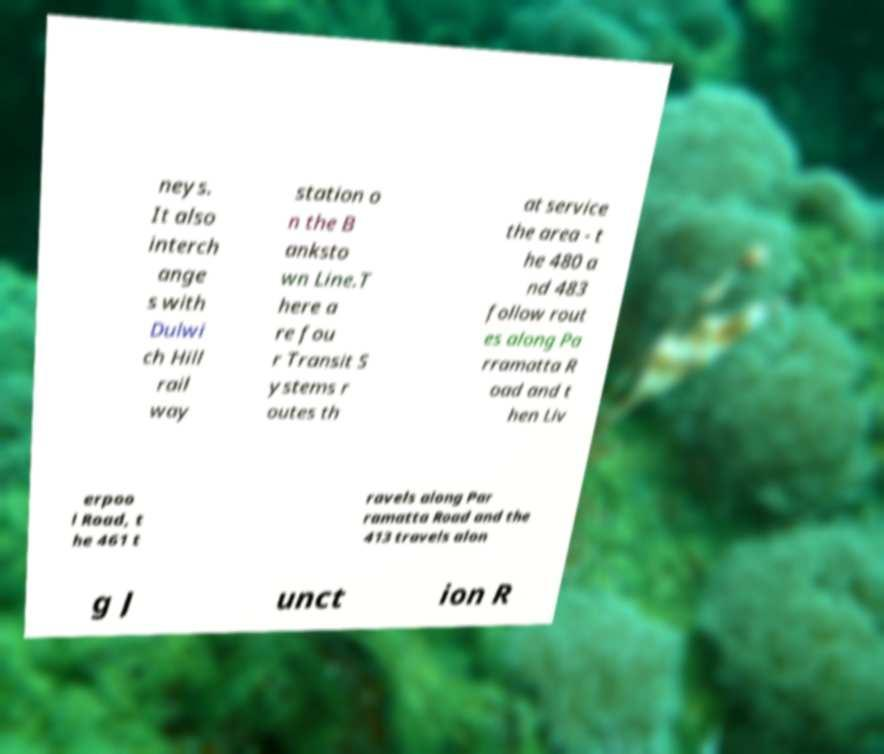For documentation purposes, I need the text within this image transcribed. Could you provide that? neys. It also interch ange s with Dulwi ch Hill rail way station o n the B anksto wn Line.T here a re fou r Transit S ystems r outes th at service the area - t he 480 a nd 483 follow rout es along Pa rramatta R oad and t hen Liv erpoo l Road, t he 461 t ravels along Par ramatta Road and the 413 travels alon g J unct ion R 